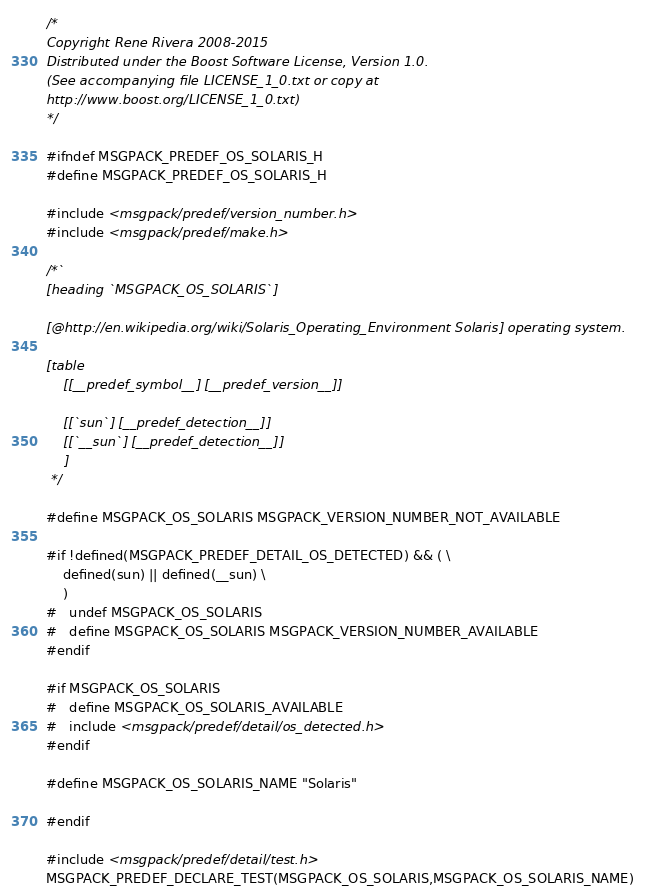Convert code to text. <code><loc_0><loc_0><loc_500><loc_500><_C_>/*
Copyright Rene Rivera 2008-2015
Distributed under the Boost Software License, Version 1.0.
(See accompanying file LICENSE_1_0.txt or copy at
http://www.boost.org/LICENSE_1_0.txt)
*/

#ifndef MSGPACK_PREDEF_OS_SOLARIS_H
#define MSGPACK_PREDEF_OS_SOLARIS_H

#include <msgpack/predef/version_number.h>
#include <msgpack/predef/make.h>

/*`
[heading `MSGPACK_OS_SOLARIS`]

[@http://en.wikipedia.org/wiki/Solaris_Operating_Environment Solaris] operating system.

[table
    [[__predef_symbol__] [__predef_version__]]

    [[`sun`] [__predef_detection__]]
    [[`__sun`] [__predef_detection__]]
    ]
 */

#define MSGPACK_OS_SOLARIS MSGPACK_VERSION_NUMBER_NOT_AVAILABLE

#if !defined(MSGPACK_PREDEF_DETAIL_OS_DETECTED) && ( \
    defined(sun) || defined(__sun) \
    )
#   undef MSGPACK_OS_SOLARIS
#   define MSGPACK_OS_SOLARIS MSGPACK_VERSION_NUMBER_AVAILABLE
#endif

#if MSGPACK_OS_SOLARIS
#   define MSGPACK_OS_SOLARIS_AVAILABLE
#   include <msgpack/predef/detail/os_detected.h>
#endif

#define MSGPACK_OS_SOLARIS_NAME "Solaris"

#endif

#include <msgpack/predef/detail/test.h>
MSGPACK_PREDEF_DECLARE_TEST(MSGPACK_OS_SOLARIS,MSGPACK_OS_SOLARIS_NAME)
</code> 